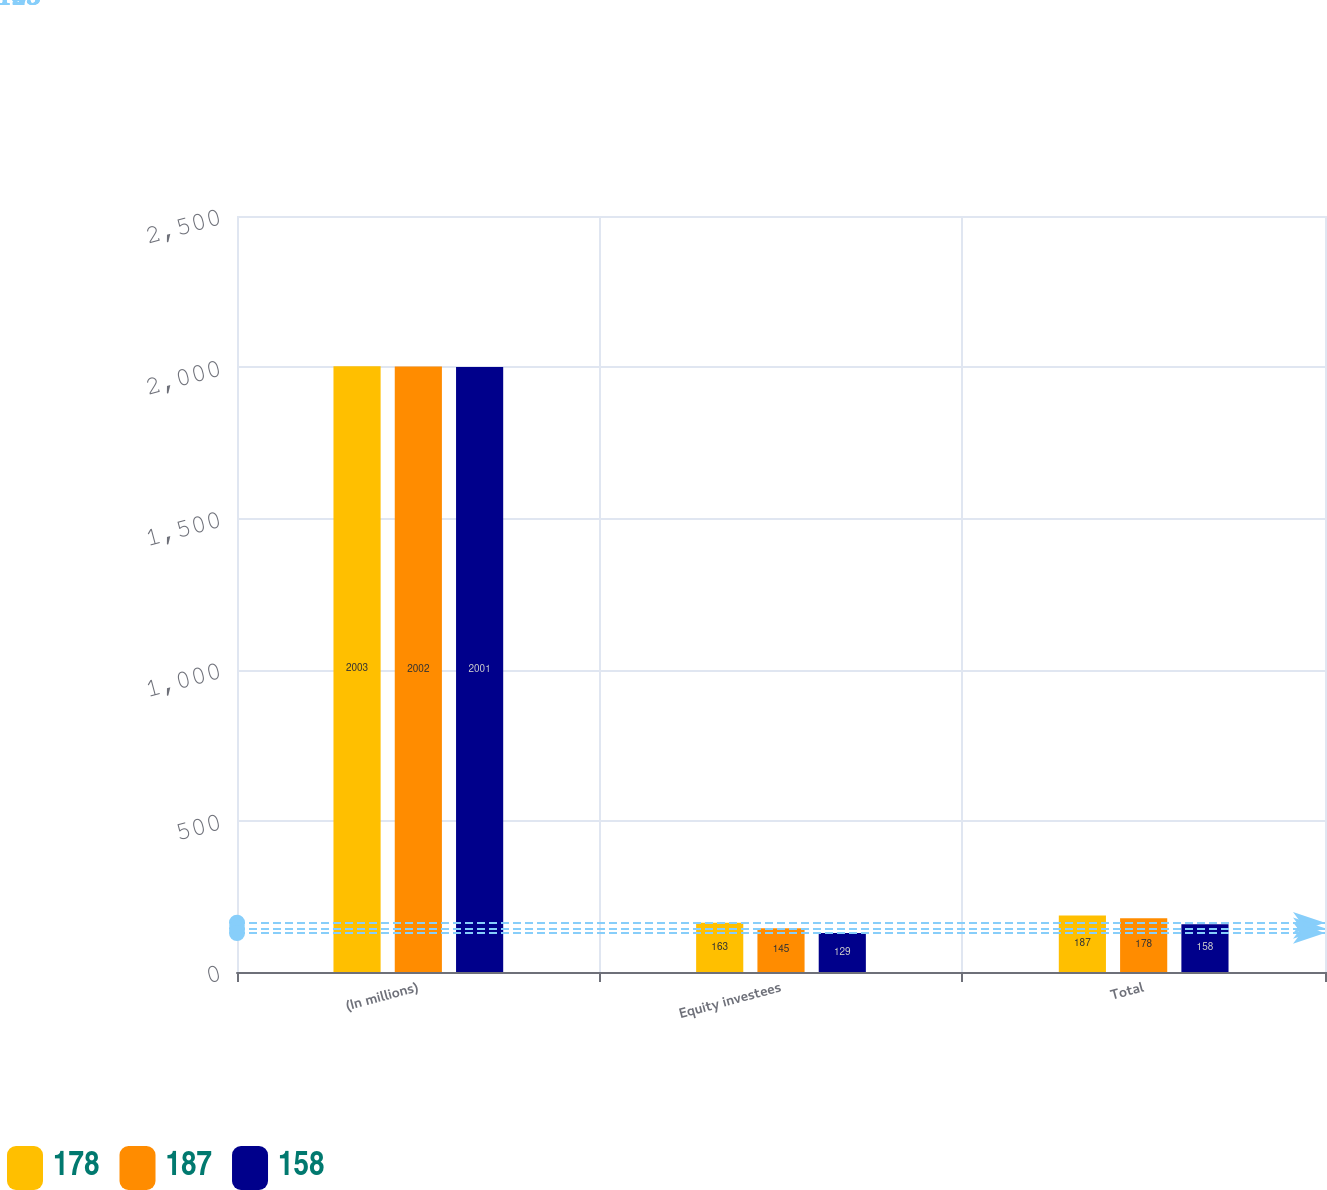Convert chart to OTSL. <chart><loc_0><loc_0><loc_500><loc_500><stacked_bar_chart><ecel><fcel>(In millions)<fcel>Equity investees<fcel>Total<nl><fcel>178<fcel>2003<fcel>163<fcel>187<nl><fcel>187<fcel>2002<fcel>145<fcel>178<nl><fcel>158<fcel>2001<fcel>129<fcel>158<nl></chart> 